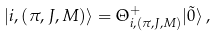<formula> <loc_0><loc_0><loc_500><loc_500>| i , ( \pi , J , M ) \rangle = \Theta ^ { + } _ { i , ( \pi , J , M ) } | \tilde { 0 } \rangle \, ,</formula> 